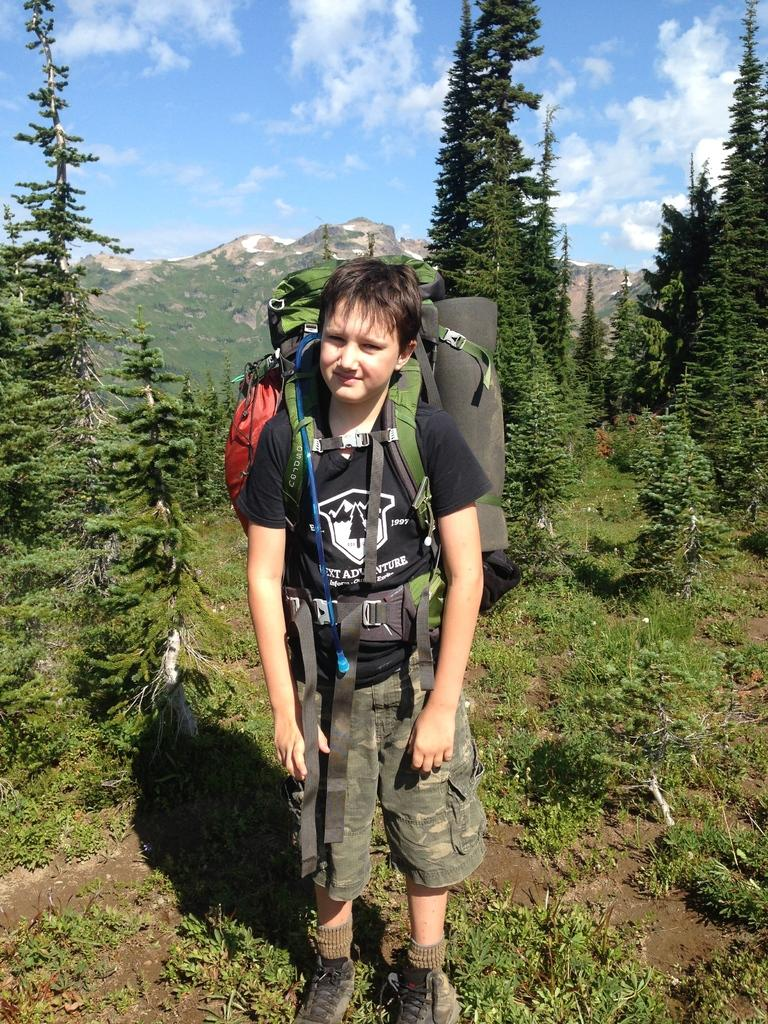Who is the main subject in the image? There is a boy in the image. What is the boy wearing? The boy is wearing a bag. Where is the boy standing? The boy is standing on the soil. What can be seen in the background of the image? There are hills and trees in the background of the image. What is visible at the top of the image? The sky is visible at the top of the image, and clouds are present in the sky. What type of pear is being used as a step in the image? There is no pear present in the image, nor is there any object being used as a step. 